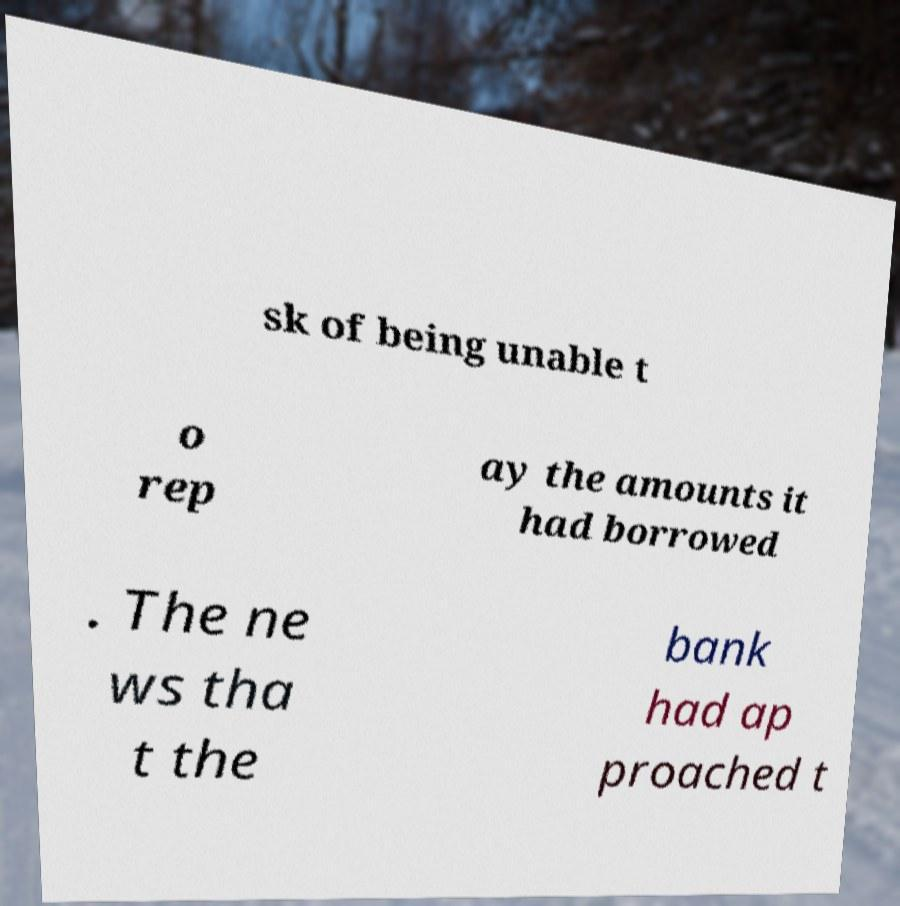What messages or text are displayed in this image? I need them in a readable, typed format. sk of being unable t o rep ay the amounts it had borrowed . The ne ws tha t the bank had ap proached t 